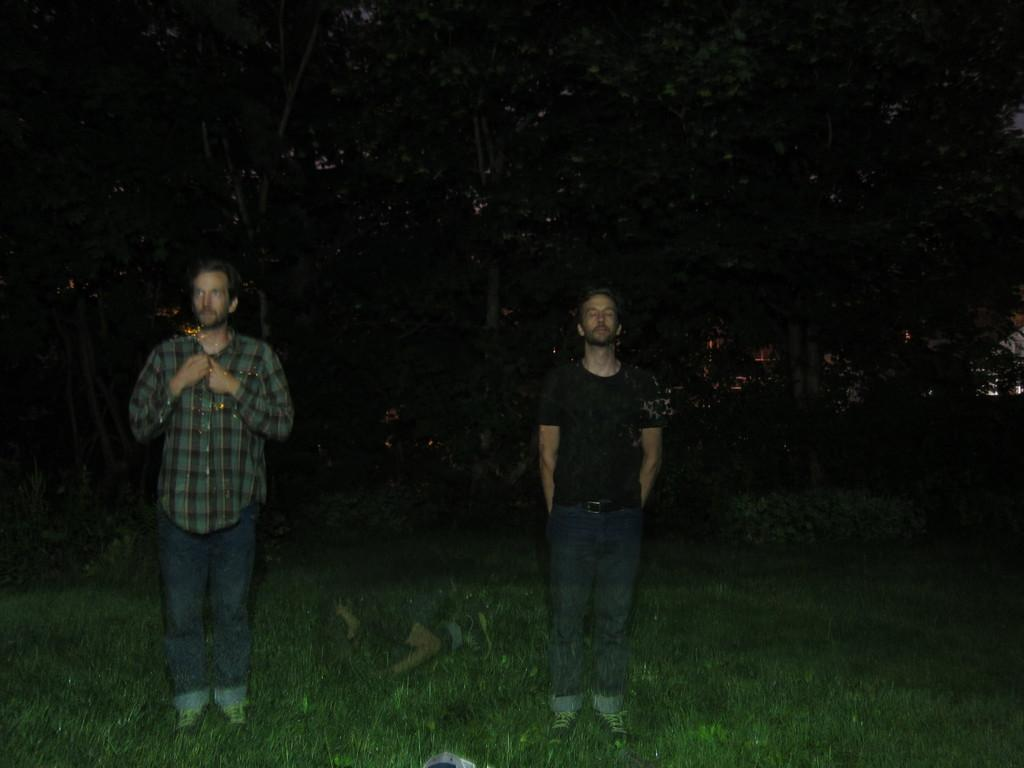How many people are standing in the grass field in the image? There are two men standing on a grass field in the image. What is the position of one of the people in the image? One person is lying on the ground. What can be seen in the background of the image? There is a group of trees in the background. What type of wine is being served in the image? There is no wine present in the image; it features two men standing on a grass field and a person lying on the ground. 